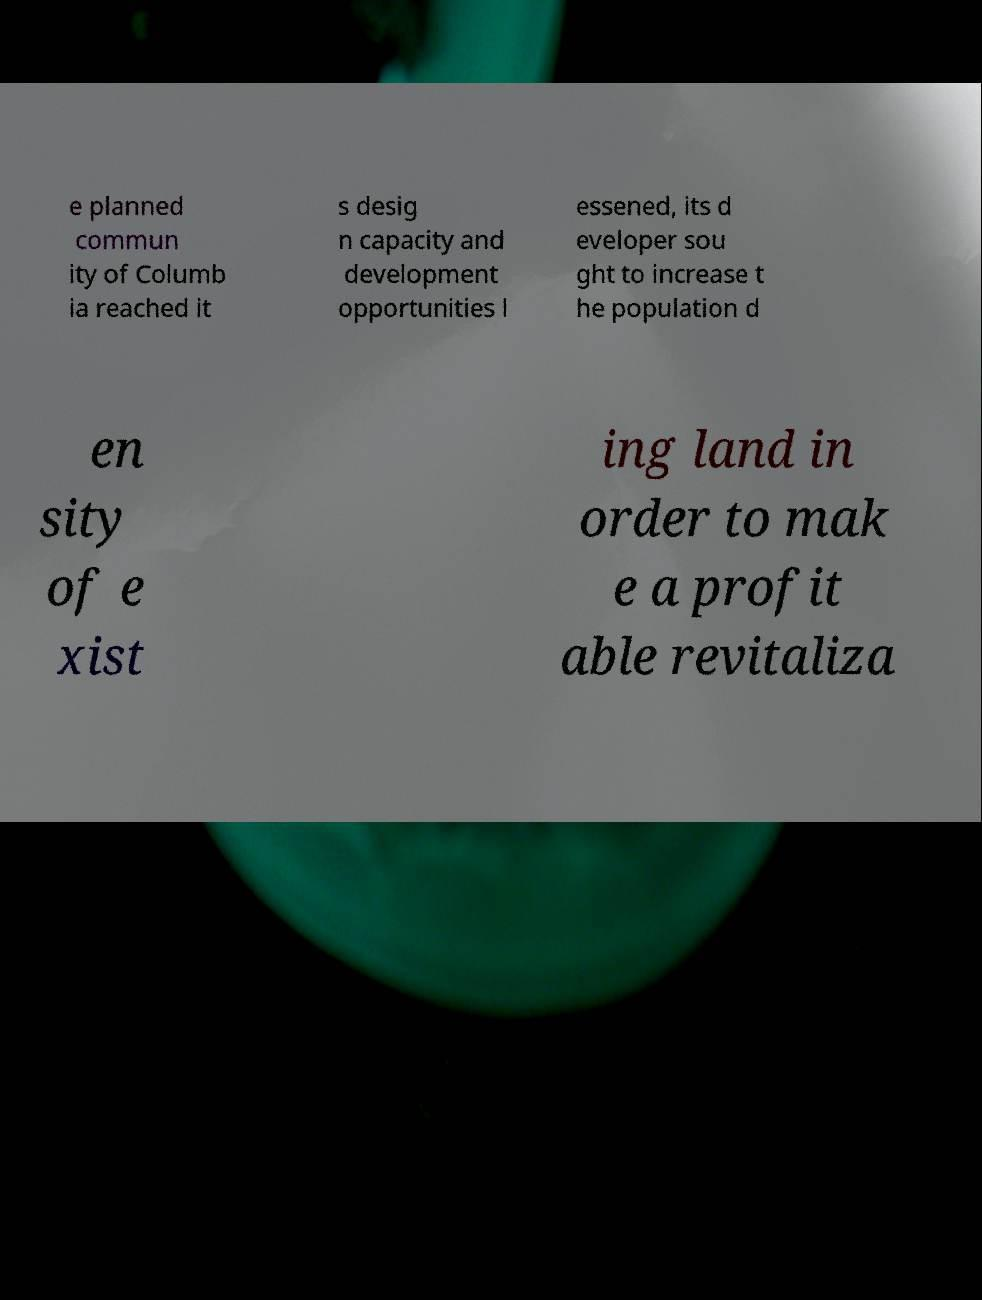Could you extract and type out the text from this image? e planned commun ity of Columb ia reached it s desig n capacity and development opportunities l essened, its d eveloper sou ght to increase t he population d en sity of e xist ing land in order to mak e a profit able revitaliza 